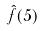<formula> <loc_0><loc_0><loc_500><loc_500>\hat { f } ( 5 )</formula> 